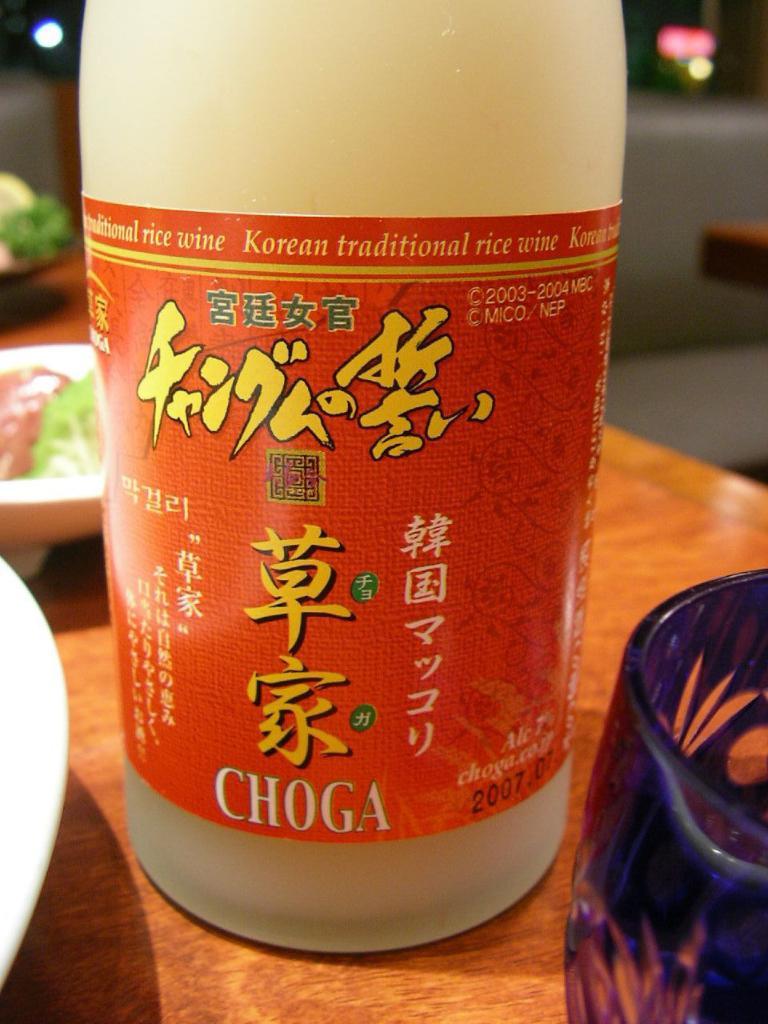What is the brand of this drink?
Provide a short and direct response. Choga. What year is printed on the label?
Your answer should be very brief. 2007. 